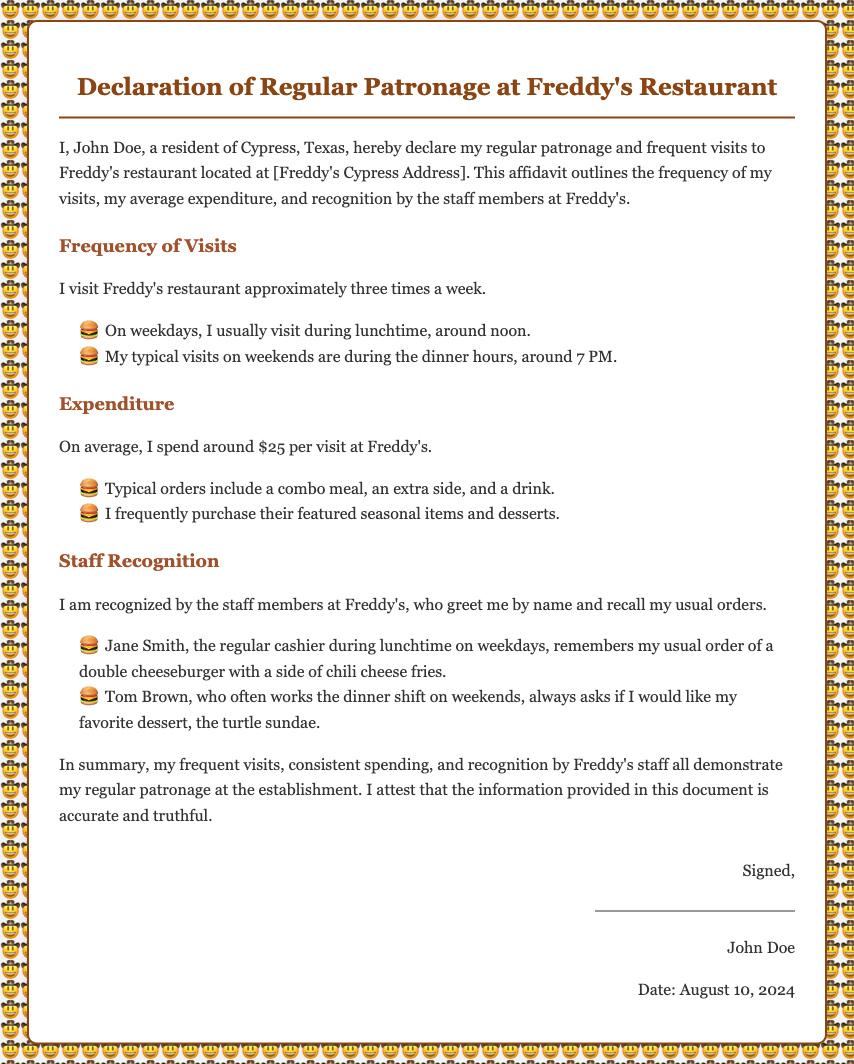What is the name of the declarant? The declarant's name is mentioned at the beginning of the affidavit.
Answer: John Doe How often does the declarant visit Freddy's? The frequency of visits is detailed under 'Frequency of Visits' in the document.
Answer: approximately three times a week What is the typical expenditure per visit? The average expenditure is specified in the 'Expenditure' section of the affidavit.
Answer: around $25 per visit Who is the cashier that recognizes the declarant during lunchtime? The document lists the name of the cashier who greets the declarant.
Answer: Jane Smith What is the usual order of the declarant during lunchtime? The usual order is provided in the context of the staff recognition section.
Answer: double cheeseburger with a side of chili cheese fries What time does the declarant typically visit on weekends? The document states the time of visits on weekends.
Answer: around 7 PM What dessert does the staff member ask if the declarant wants? The dessert inquiry is included in the recognition detail about the declarant's favorites.
Answer: turtle sundae How does the declarant describe the staff's recognition? The explanation of recognition is given in the 'Staff Recognition' section.
Answer: greet me by name and recall my usual orders What is the purpose of this document? The intention of the document is outlined in the introduction.
Answer: declare my regular patronage and frequent visits 